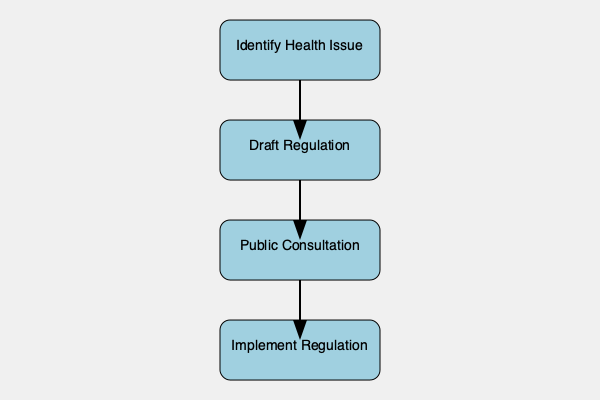In the flowchart depicting the process of implementing new health regulations for small businesses, which step directly precedes the "Implement Regulation" phase? To answer this question, we need to analyze the flowchart step by step:

1. The flowchart shows four main steps in the process of implementing new health regulations for small businesses.

2. The steps are arranged vertically, with arrows indicating the flow from one step to the next.

3. The steps in order are:
   a) Identify Health Issue
   b) Draft Regulation
   c) Public Consultation
   d) Implement Regulation

4. We can see that each step leads directly to the next one.

5. The question asks about the step that comes immediately before "Implement Regulation."

6. Looking at the flowchart, we can see that "Public Consultation" is the step directly above "Implement Regulation," with an arrow connecting them.

Therefore, the step that directly precedes the "Implement Regulation" phase is "Public Consultation."
Answer: Public Consultation 